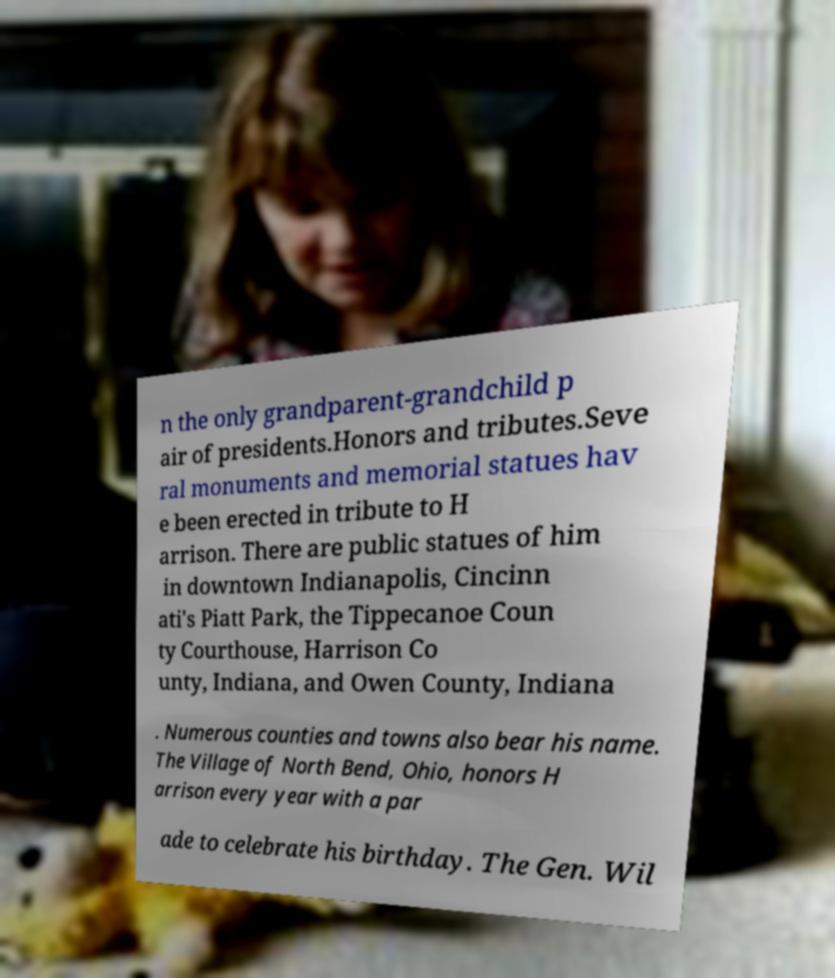Please identify and transcribe the text found in this image. n the only grandparent-grandchild p air of presidents.Honors and tributes.Seve ral monuments and memorial statues hav e been erected in tribute to H arrison. There are public statues of him in downtown Indianapolis, Cincinn ati's Piatt Park, the Tippecanoe Coun ty Courthouse, Harrison Co unty, Indiana, and Owen County, Indiana . Numerous counties and towns also bear his name. The Village of North Bend, Ohio, honors H arrison every year with a par ade to celebrate his birthday. The Gen. Wil 